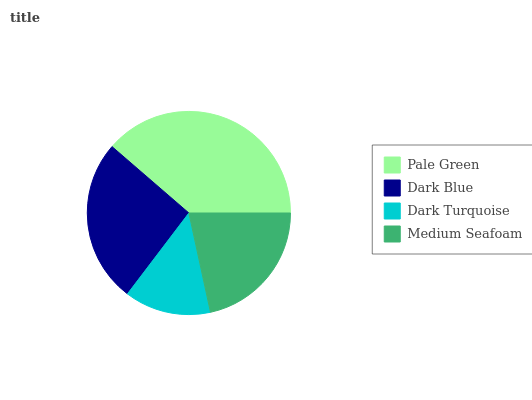Is Dark Turquoise the minimum?
Answer yes or no. Yes. Is Pale Green the maximum?
Answer yes or no. Yes. Is Dark Blue the minimum?
Answer yes or no. No. Is Dark Blue the maximum?
Answer yes or no. No. Is Pale Green greater than Dark Blue?
Answer yes or no. Yes. Is Dark Blue less than Pale Green?
Answer yes or no. Yes. Is Dark Blue greater than Pale Green?
Answer yes or no. No. Is Pale Green less than Dark Blue?
Answer yes or no. No. Is Dark Blue the high median?
Answer yes or no. Yes. Is Medium Seafoam the low median?
Answer yes or no. Yes. Is Dark Turquoise the high median?
Answer yes or no. No. Is Pale Green the low median?
Answer yes or no. No. 